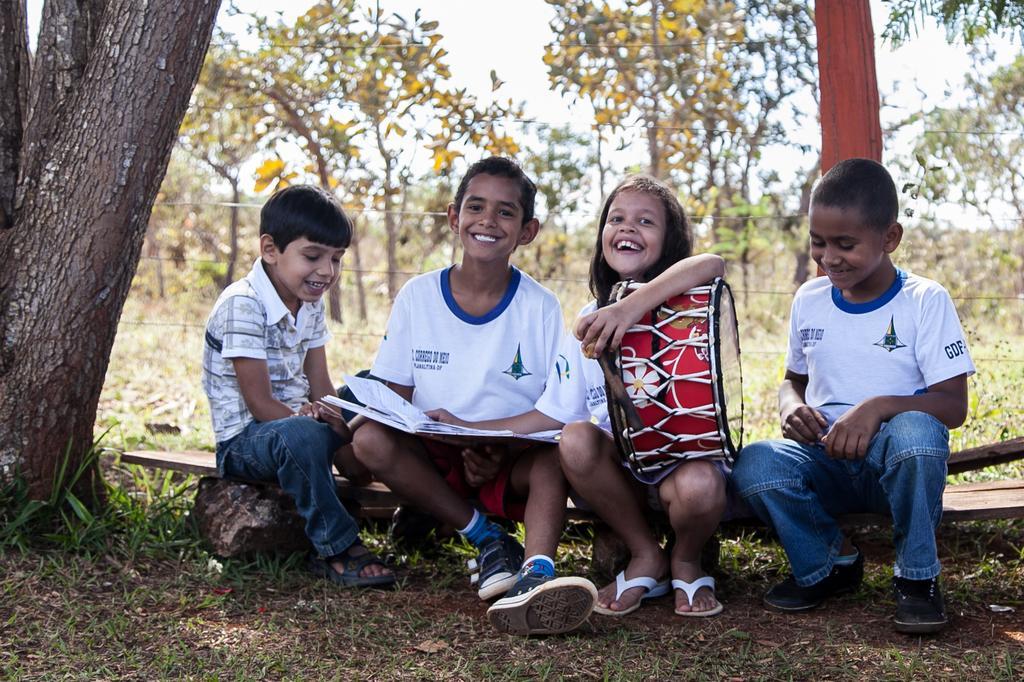Describe this image in one or two sentences. In this image I can see few children are sitting. I can see all of them are wearing white colour t shirt. I can also see smile on their faces and here I can see she is holding a drum. I can also see a book over here and in the background I can see number of trees. 